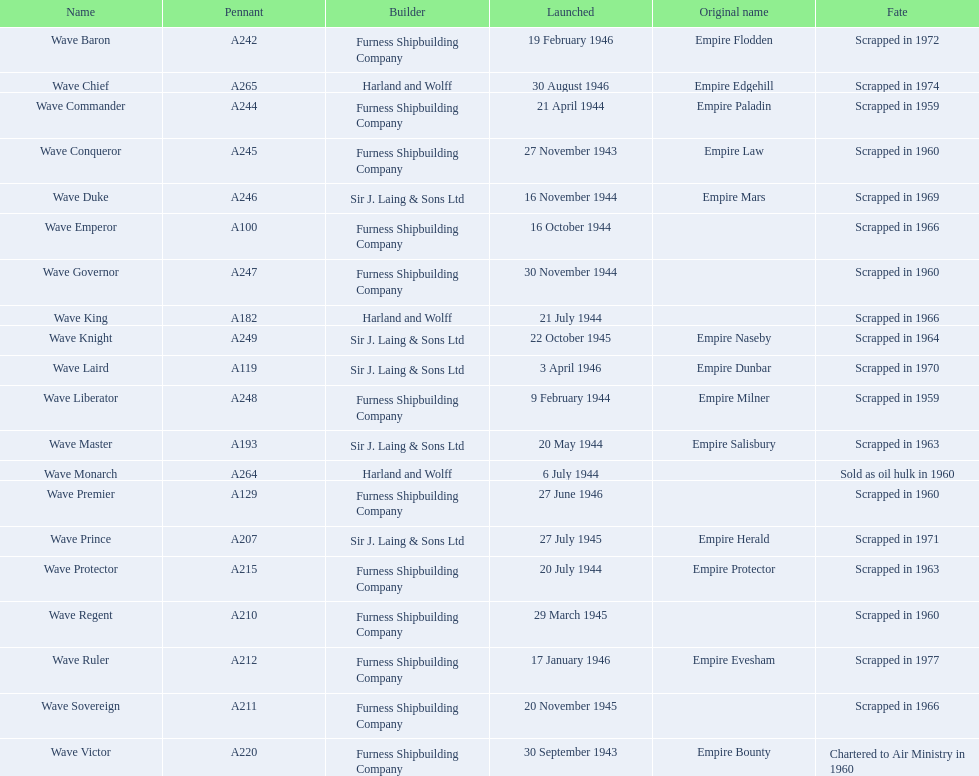When was the wave victor initiated? 30 September 1943. What other oiler was set in motion during that same year? Wave Conqueror. 